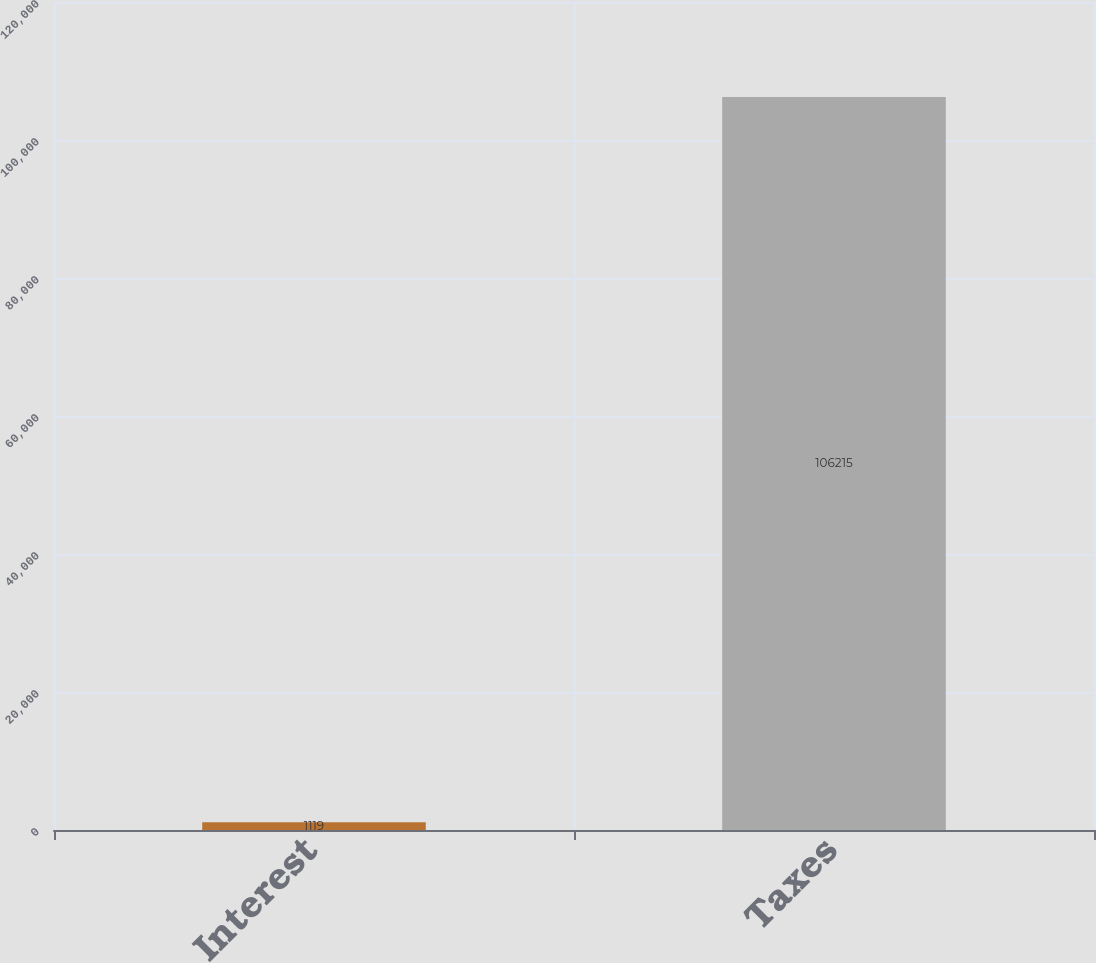Convert chart. <chart><loc_0><loc_0><loc_500><loc_500><bar_chart><fcel>Interest<fcel>Taxes<nl><fcel>1119<fcel>106215<nl></chart> 